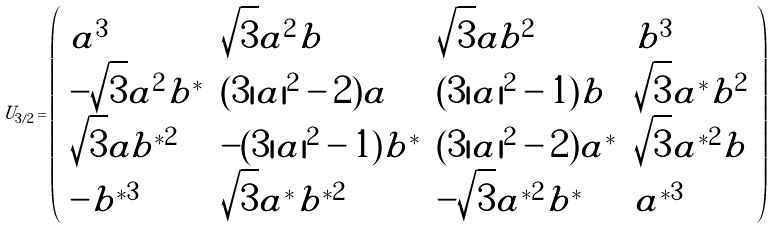Convert formula to latex. <formula><loc_0><loc_0><loc_500><loc_500>U _ { 3 / 2 } = \left ( \begin{array} { l l l l } a ^ { 3 } & \sqrt { 3 } a ^ { 2 } b & \sqrt { 3 } a b ^ { 2 } & b ^ { 3 } \\ - \sqrt { 3 } a ^ { 2 } b ^ { * } & ( 3 | a | ^ { 2 } - 2 ) a & ( 3 | a | ^ { 2 } - 1 ) b & \sqrt { 3 } a ^ { * } b ^ { 2 } \\ \sqrt { 3 } a b ^ { * 2 } & - ( 3 | a | ^ { 2 } - 1 ) b ^ { * } & ( 3 | a | ^ { 2 } - 2 ) a ^ { * } & \sqrt { 3 } a ^ { * 2 } b \\ - b ^ { * 3 } & \sqrt { 3 } a ^ { * } b ^ { * 2 } & - \sqrt { 3 } a ^ { * 2 } b ^ { * } & a ^ { * 3 } \end{array} \right )</formula> 